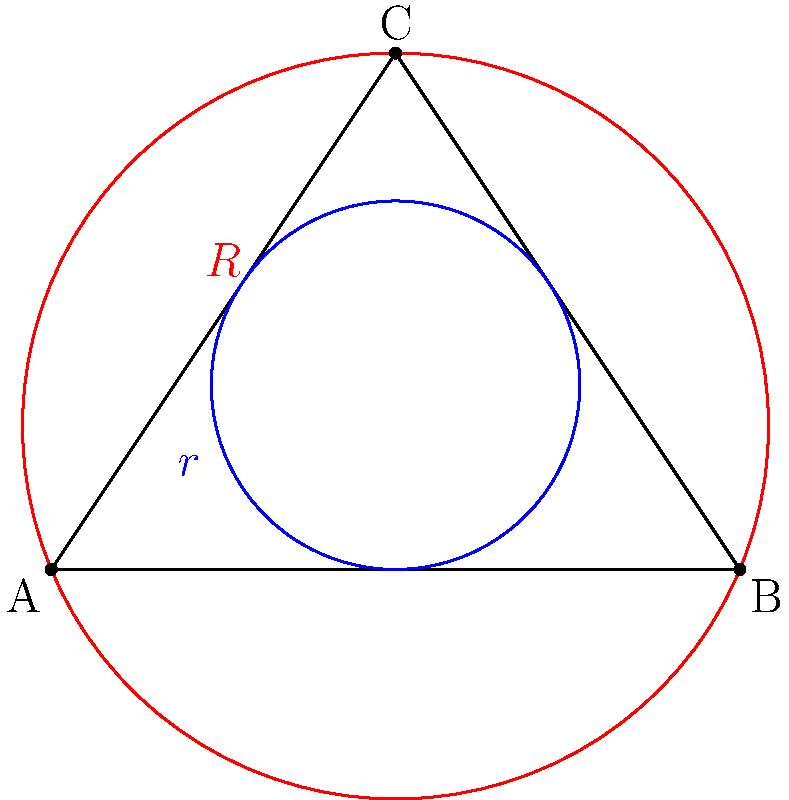In a triangle ABC, let $r$ be the radius of the inscribed circle and $R$ be the radius of the circumscribed circle. Given that the area of the triangle is 6 square units, and the ratio of $R$ to $r$ is 4:1, determine the value of $R$ in terms of $\pi$. Let's approach this step-by-step:

1) First, recall the formula relating the area of a triangle to its semiperimeter and inradius:
   $A = rs$, where $A$ is the area, $r$ is the inradius, and $s$ is the semiperimeter.

2) We're given that the area $A = 6$ square units, so:
   $6 = rs$

3) Next, recall the formula relating the area of a triangle to its circumradius:
   $A = \frac{abc}{4R}$, where $a$, $b$, and $c$ are the side lengths of the triangle.

4) Substituting our known area:
   $6 = \frac{abc}{4R}$

5) We're told that $R:r = 4:1$, so $R = 4r$. Let's substitute this into our equation from step 2:
   $6 = r \cdot \frac{abc}{16r} = \frac{abc}{16}$

6) Now we can equate our two expressions for the area:
   $rs = \frac{abc}{16}$

7) Simplify:
   $16rs = abc$

8) Recall that $s = \frac{a+b+c}{2}$. Substitute this:
   $16r \cdot \frac{a+b+c}{2} = abc$

9) Simplify:
   $8r(a+b+c) = abc$

10) This is a known relationship between the inradius, circumradius, and side lengths of a triangle:
    $r(a+b+c) = R \cdot abc$

11) Therefore, $8r = R$, which confirms our given ratio $R:r = 4:1$.

12) Now, let's use the formula from step 3 with our known values:
    $6 = \frac{abc}{4R}$

13) Solve for $R$:
    $R = \frac{abc}{24}$

14) But we don't know $abc$. However, we can use the formula from step 1:
    $6 = rs = R \cdot \frac{r}{4} \cdot s = R \cdot \frac{1}{4} \cdot \frac{abc}{4R} = \frac{abc}{16}$

15) Therefore, $abc = 96$

16) Substitute this back into our equation for $R$:
    $R = \frac{96}{24} = 4$

17) The question asks for $R$ in terms of $\pi$, so our final answer is:
    $R = \frac{4}{\pi}\pi$
Answer: $\frac{4}{\pi}\pi$ 